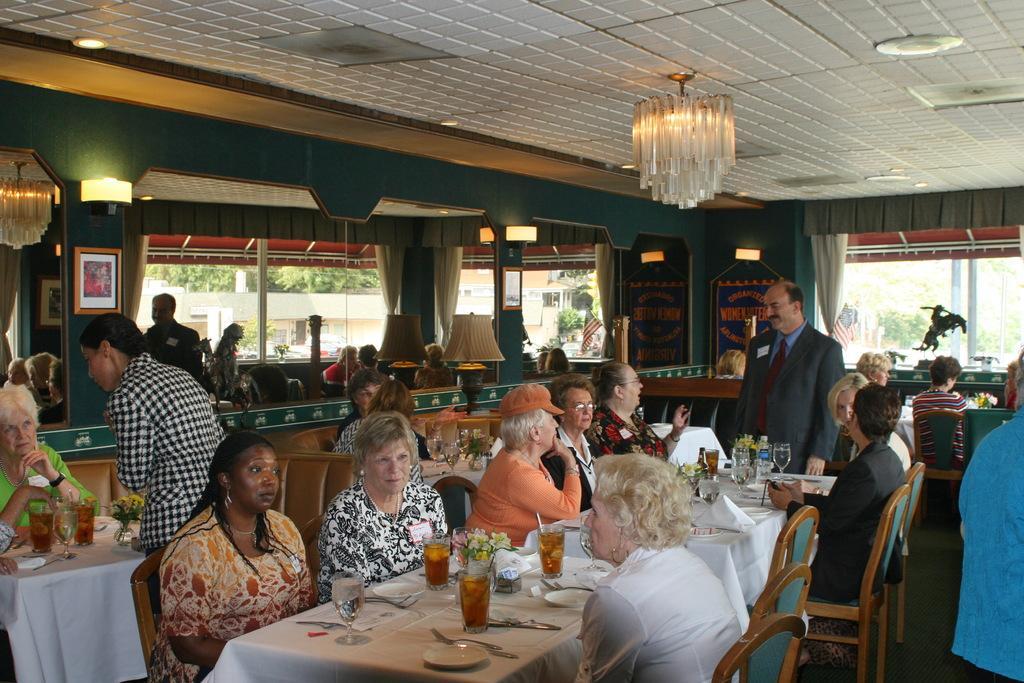Can you describe this image briefly? Here we can see few persons are sitting on the chairs. There are tablecloths, glasses, flower vases, spoons, plates, bottles, and bowls. There are few persons standing on the floor. Here we can see glasses, curtains, flags, lights, lamp, and frames. From the glasses we can see trees and a building. Here we can see ceiling. 